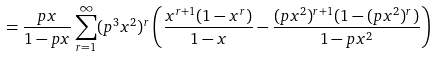Convert formula to latex. <formula><loc_0><loc_0><loc_500><loc_500>= \frac { p x } { 1 - p x } \sum _ { r = 1 } ^ { \infty } ( p ^ { 3 } x ^ { 2 } ) ^ { r } \left ( \frac { x ^ { r + 1 } ( 1 - x ^ { r } ) } { 1 - x } - \frac { ( p x ^ { 2 } ) ^ { r + 1 } ( 1 - ( p x ^ { 2 } ) ^ { r } ) } { 1 - p x ^ { 2 } } \right )</formula> 